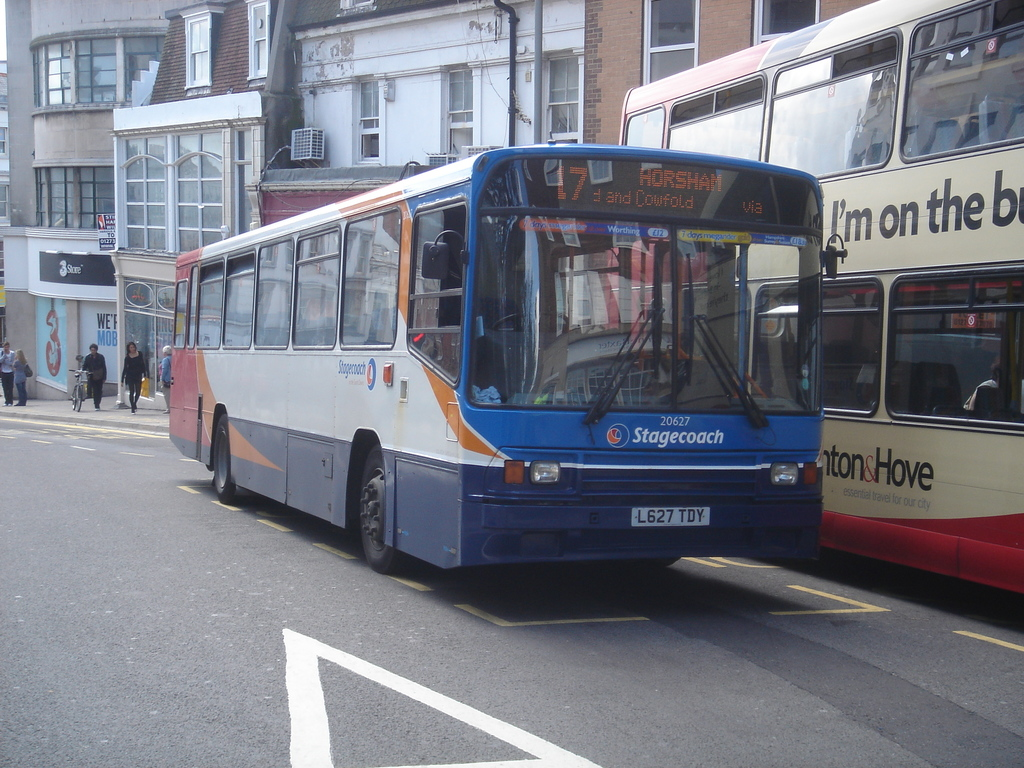What details can you tell me about the two buses shown in the image? The image features two buses in an urban setting. The foremost bus, numbered 17 and operated by Stagecoach, is headed to Horsham via Cowford. It's a single-decker bus with a blue and orange livery. Meanwhile, the other bus, also a Stagecoach, is a double-decker model, providing insight into varied bus types servicing the area. 